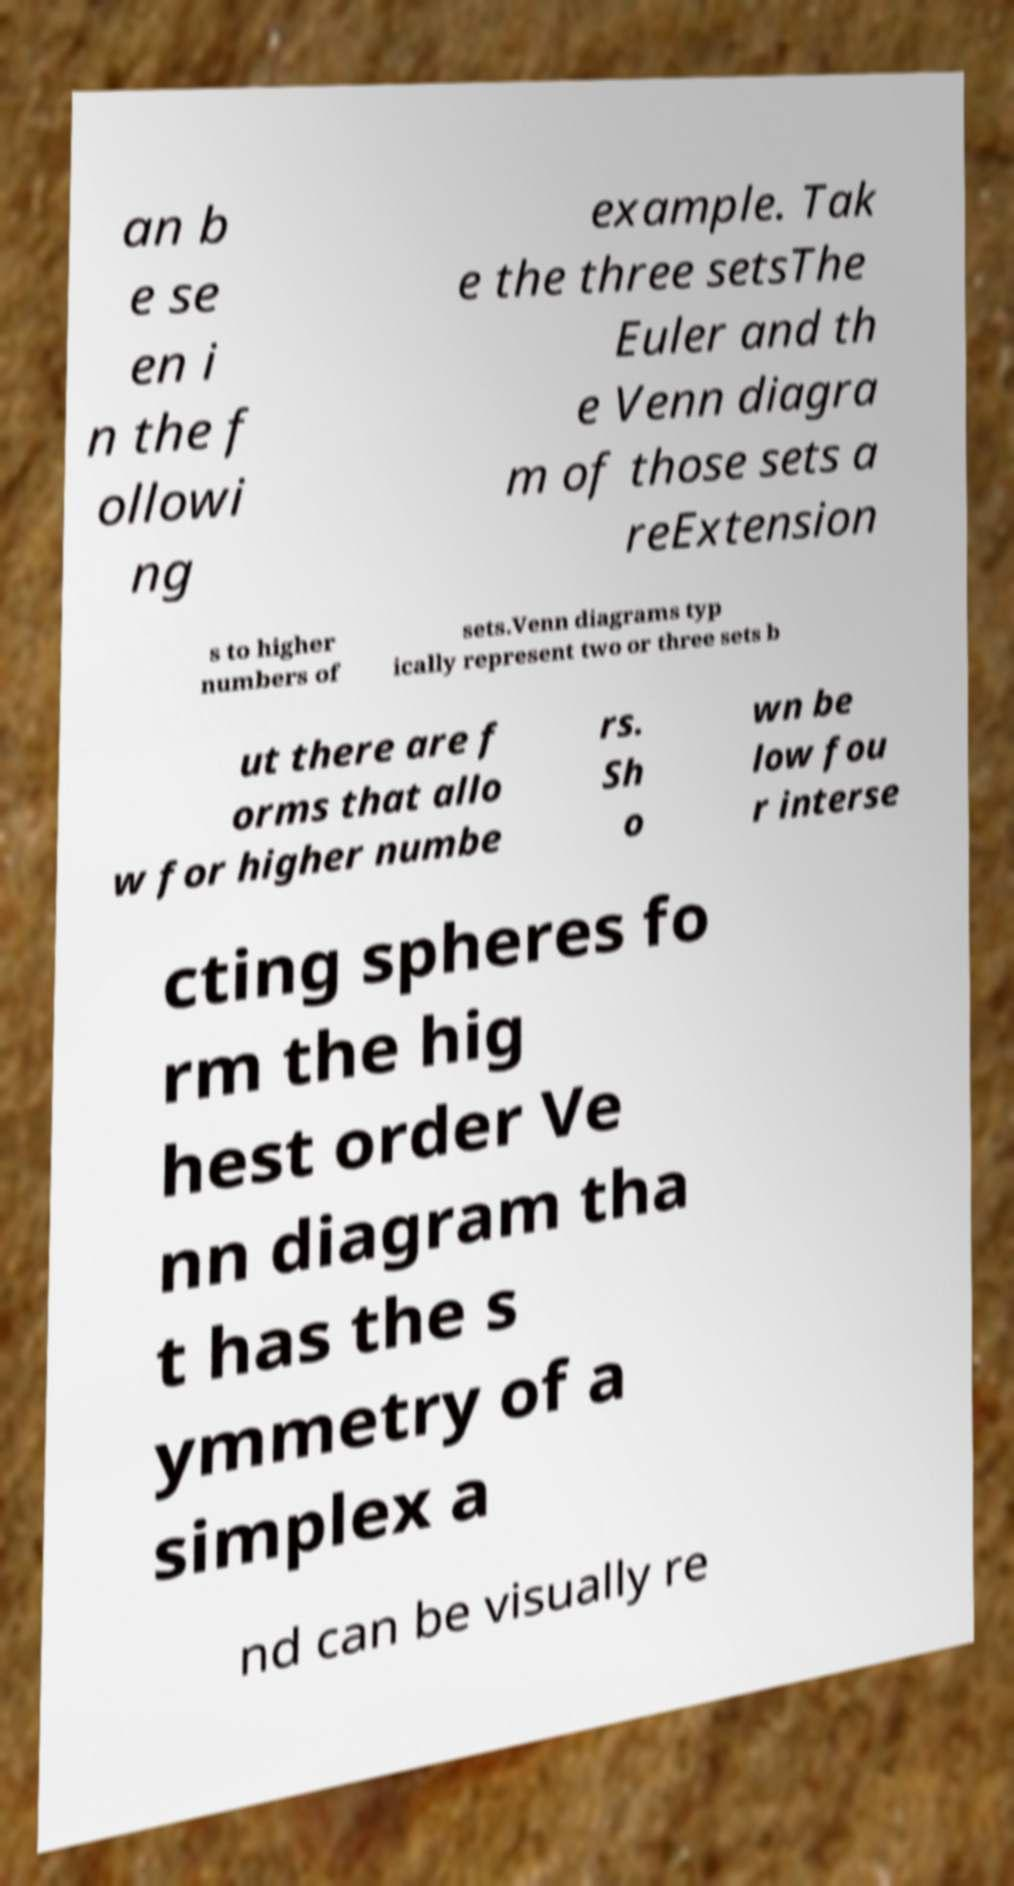Can you read and provide the text displayed in the image?This photo seems to have some interesting text. Can you extract and type it out for me? an b e se en i n the f ollowi ng example. Tak e the three setsThe Euler and th e Venn diagra m of those sets a reExtension s to higher numbers of sets.Venn diagrams typ ically represent two or three sets b ut there are f orms that allo w for higher numbe rs. Sh o wn be low fou r interse cting spheres fo rm the hig hest order Ve nn diagram tha t has the s ymmetry of a simplex a nd can be visually re 